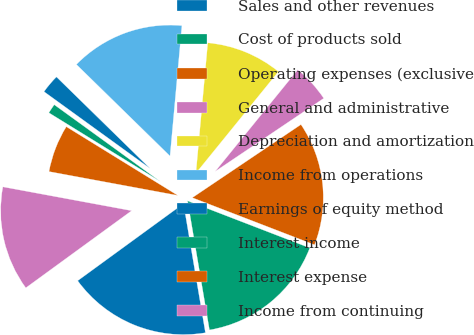Convert chart. <chart><loc_0><loc_0><loc_500><loc_500><pie_chart><fcel>Sales and other revenues<fcel>Cost of products sold<fcel>Operating expenses (exclusive<fcel>General and administrative<fcel>Depreciation and amortization<fcel>Income from operations<fcel>Earnings of equity method<fcel>Interest income<fcel>Interest expense<fcel>Income from continuing<nl><fcel>17.65%<fcel>16.47%<fcel>15.29%<fcel>4.71%<fcel>9.41%<fcel>14.12%<fcel>2.35%<fcel>1.18%<fcel>5.88%<fcel>12.94%<nl></chart> 